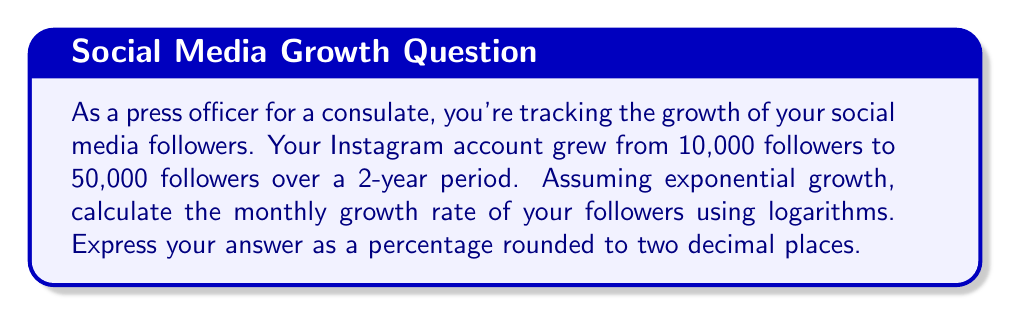Show me your answer to this math problem. To solve this problem, we'll use the exponential growth formula and logarithms:

$$ A = P(1 + r)^t $$

Where:
A = Final amount (50,000 followers)
P = Initial amount (10,000 followers)
r = Monthly growth rate (what we're solving for)
t = Time period (24 months)

Let's apply logarithms to both sides of the equation:

$$ \log A = \log[P(1 + r)^t] $$

Using the properties of logarithms, we can simplify:

$$ \log A = \log P + t \log(1 + r) $$

Now, let's substitute our known values:

$$ \log 50000 = \log 10000 + 24 \log(1 + r) $$

Simplify:

$$ 4.69897 = 4 + 24 \log(1 + r) $$

Subtract 4 from both sides:

$$ 0.69897 = 24 \log(1 + r) $$

Divide both sides by 24:

$$ 0.02912 = \log(1 + r) $$

Now, we need to apply the inverse function (exponential) to both sides:

$$ 10^{0.02912} = 1 + r $$

$$ 1.06944 = 1 + r $$

Subtract 1 from both sides:

$$ 0.06944 = r $$

Convert to a percentage by multiplying by 100:

$$ 6.944\% \approx 6.94\% $$
Answer: The monthly growth rate of social media followers is approximately 6.94%. 